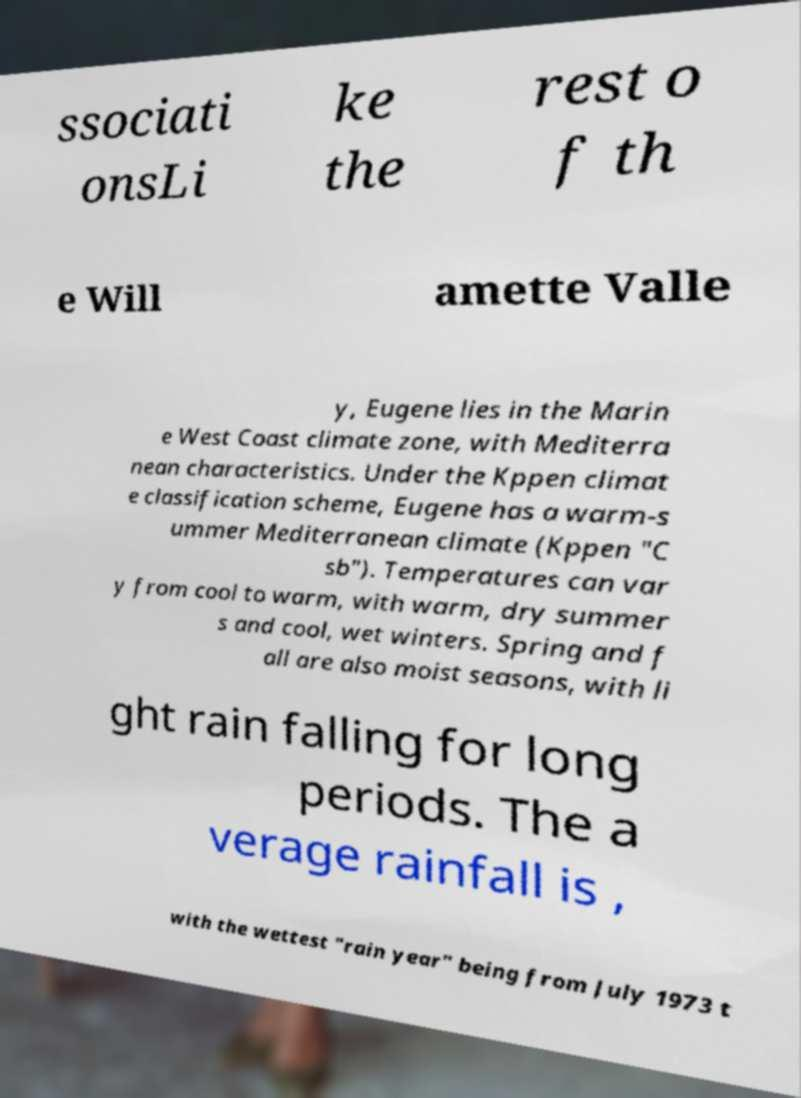There's text embedded in this image that I need extracted. Can you transcribe it verbatim? ssociati onsLi ke the rest o f th e Will amette Valle y, Eugene lies in the Marin e West Coast climate zone, with Mediterra nean characteristics. Under the Kppen climat e classification scheme, Eugene has a warm-s ummer Mediterranean climate (Kppen "C sb"). Temperatures can var y from cool to warm, with warm, dry summer s and cool, wet winters. Spring and f all are also moist seasons, with li ght rain falling for long periods. The a verage rainfall is , with the wettest "rain year" being from July 1973 t 